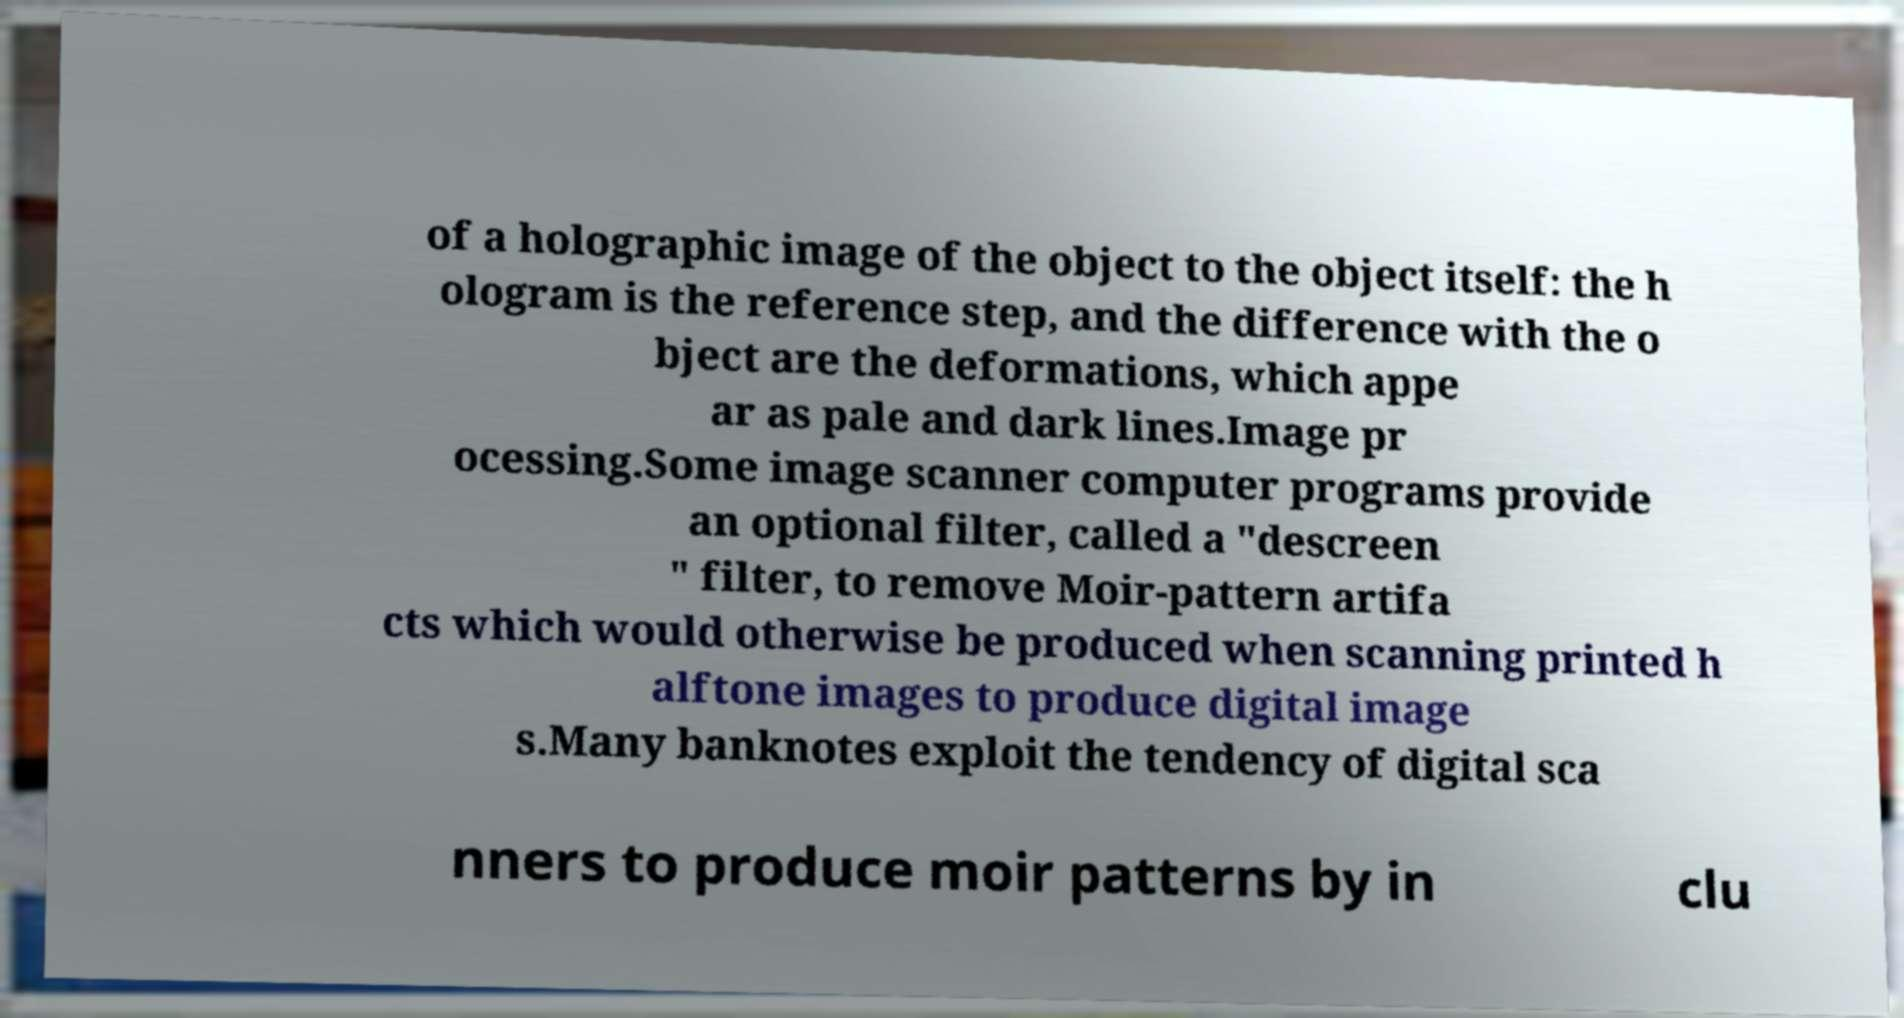Can you accurately transcribe the text from the provided image for me? of a holographic image of the object to the object itself: the h ologram is the reference step, and the difference with the o bject are the deformations, which appe ar as pale and dark lines.Image pr ocessing.Some image scanner computer programs provide an optional filter, called a "descreen " filter, to remove Moir-pattern artifa cts which would otherwise be produced when scanning printed h alftone images to produce digital image s.Many banknotes exploit the tendency of digital sca nners to produce moir patterns by in clu 